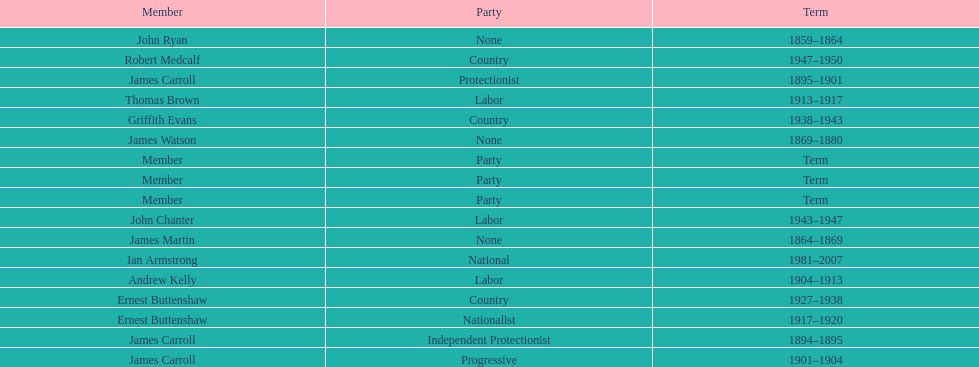How long did ian armstrong serve? 26 years. 